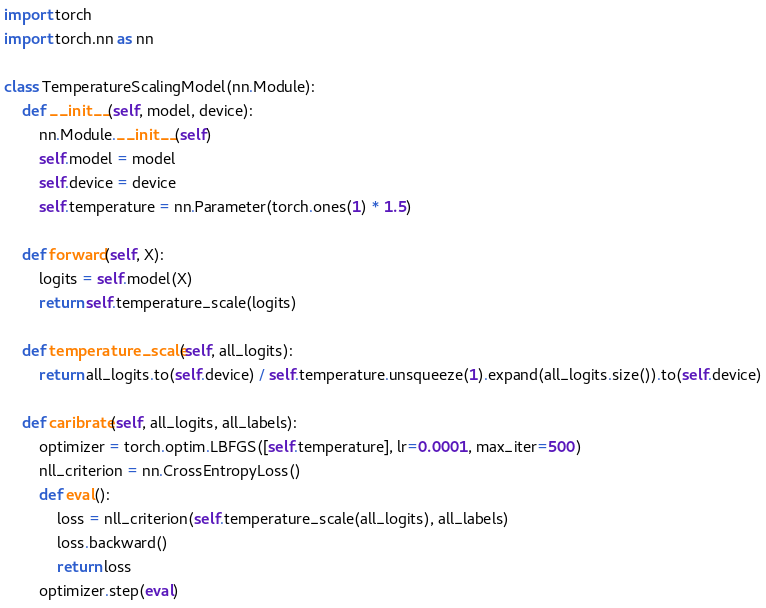<code> <loc_0><loc_0><loc_500><loc_500><_Python_>import torch
import torch.nn as nn

class TemperatureScalingModel(nn.Module):
    def __init__(self, model, device):
        nn.Module.__init__(self)
        self.model = model
        self.device = device
        self.temperature = nn.Parameter(torch.ones(1) * 1.5)

    def forward(self, X):
        logits = self.model(X)
        return self.temperature_scale(logits)

    def temperature_scale(self, all_logits):
        return all_logits.to(self.device) / self.temperature.unsqueeze(1).expand(all_logits.size()).to(self.device)

    def caribrate(self, all_logits, all_labels):
        optimizer = torch.optim.LBFGS([self.temperature], lr=0.0001, max_iter=500)
        nll_criterion = nn.CrossEntropyLoss()
        def eval():
            loss = nll_criterion(self.temperature_scale(all_logits), all_labels)
            loss.backward()
            return loss
        optimizer.step(eval)

</code> 